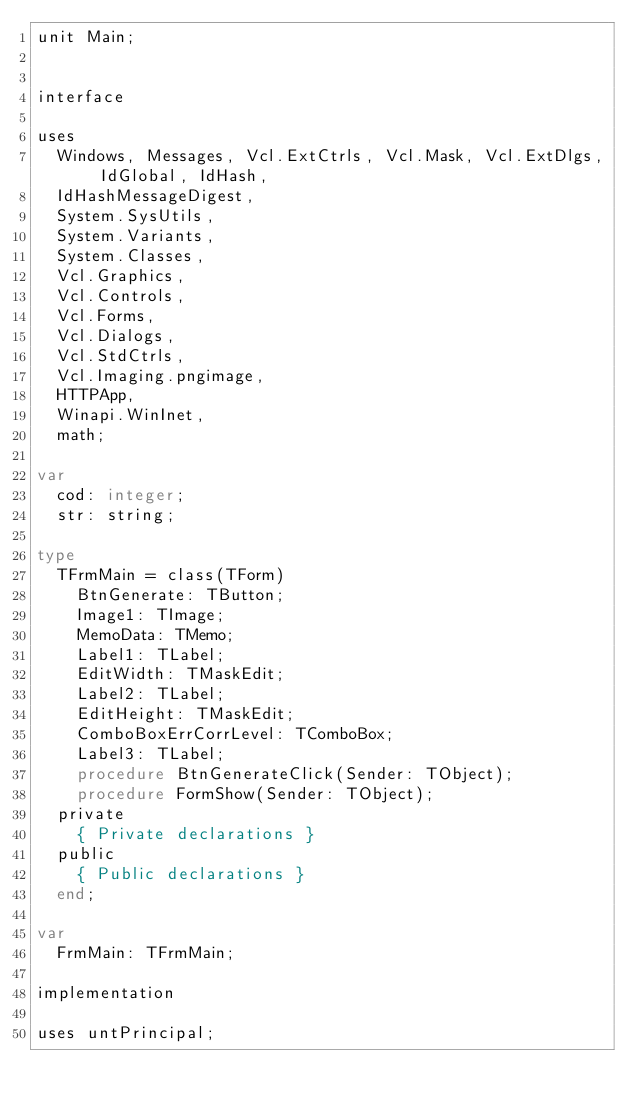<code> <loc_0><loc_0><loc_500><loc_500><_Pascal_>unit Main;

interface

uses
  Windows, Messages, Vcl.ExtCtrls, Vcl.Mask, Vcl.ExtDlgs, IdGlobal, IdHash,
  IdHashMessageDigest,
  System.SysUtils,
  System.Variants,
  System.Classes,
  Vcl.Graphics,
  Vcl.Controls,
  Vcl.Forms,
  Vcl.Dialogs,
  Vcl.StdCtrls,
  Vcl.Imaging.pngimage,
  HTTPApp,
  Winapi.WinInet,
  math;

var
  cod: integer;
  str: string;

type
  TFrmMain = class(TForm)
    BtnGenerate: TButton;
    Image1: TImage;
    MemoData: TMemo;
    Label1: TLabel;
    EditWidth: TMaskEdit;
    Label2: TLabel;
    EditHeight: TMaskEdit;
    ComboBoxErrCorrLevel: TComboBox;
    Label3: TLabel;
    procedure BtnGenerateClick(Sender: TObject);
    procedure FormShow(Sender: TObject);
  private
    { Private declarations }
  public
    { Public declarations }
  end;

var
  FrmMain: TFrmMain;

implementation

uses untPrincipal;</code> 